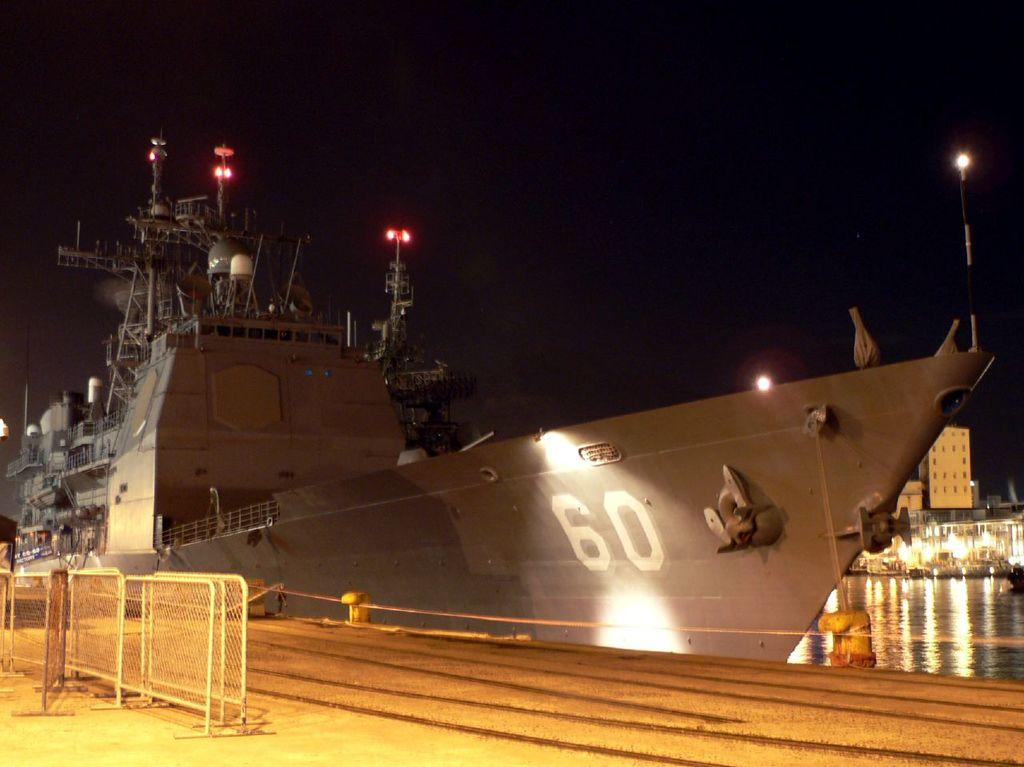<image>
Share a concise interpretation of the image provided. A large, grey military sea vessel marked with the number 60 is docked. 